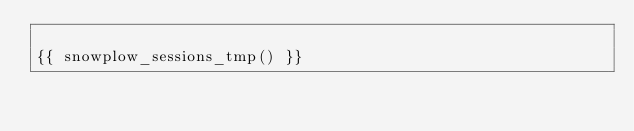Convert code to text. <code><loc_0><loc_0><loc_500><loc_500><_SQL_>
{{ snowplow_sessions_tmp() }}
</code> 